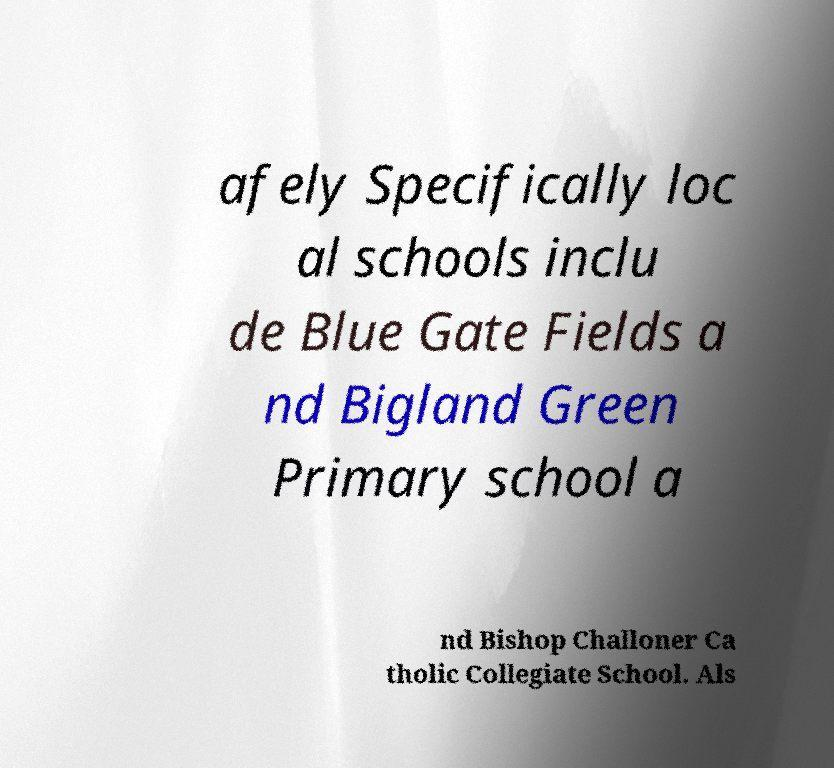I need the written content from this picture converted into text. Can you do that? afely Specifically loc al schools inclu de Blue Gate Fields a nd Bigland Green Primary school a nd Bishop Challoner Ca tholic Collegiate School. Als 